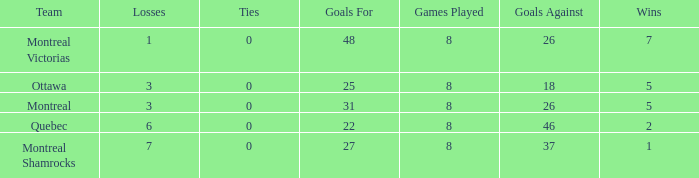For teams with 7 wins, what is the number of goals against? 26.0. 